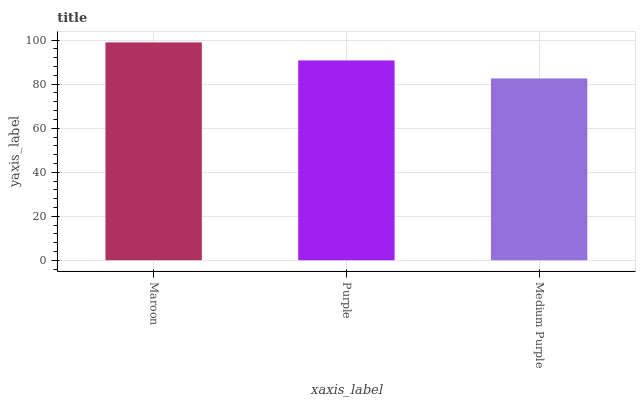Is Medium Purple the minimum?
Answer yes or no. Yes. Is Maroon the maximum?
Answer yes or no. Yes. Is Purple the minimum?
Answer yes or no. No. Is Purple the maximum?
Answer yes or no. No. Is Maroon greater than Purple?
Answer yes or no. Yes. Is Purple less than Maroon?
Answer yes or no. Yes. Is Purple greater than Maroon?
Answer yes or no. No. Is Maroon less than Purple?
Answer yes or no. No. Is Purple the high median?
Answer yes or no. Yes. Is Purple the low median?
Answer yes or no. Yes. Is Medium Purple the high median?
Answer yes or no. No. Is Medium Purple the low median?
Answer yes or no. No. 